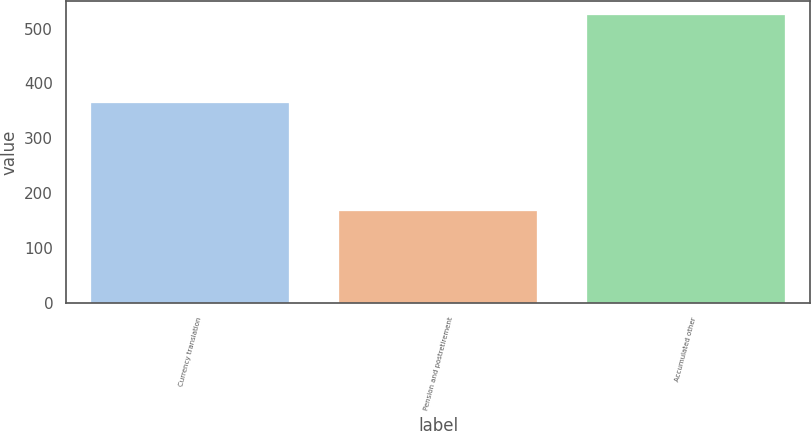<chart> <loc_0><loc_0><loc_500><loc_500><bar_chart><fcel>Currency translation<fcel>Pension and postretirement<fcel>Accumulated other<nl><fcel>364<fcel>168<fcel>524<nl></chart> 